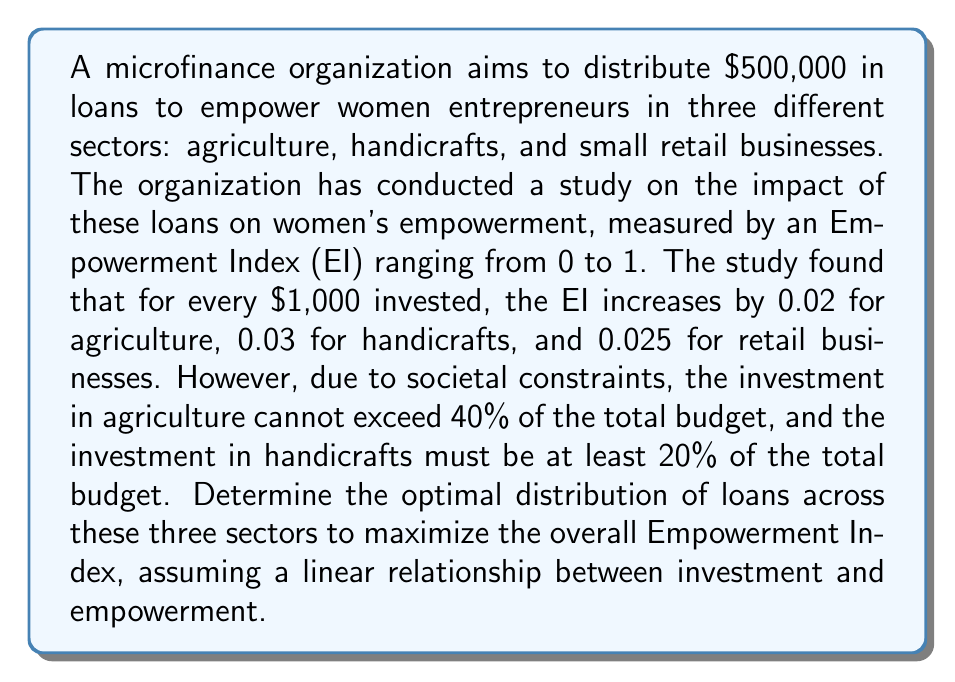Give your solution to this math problem. This problem can be solved using linear programming. Let's define our variables and constraints:

Variables:
$x_1$ = Amount invested in agriculture (in thousands of dollars)
$x_2$ = Amount invested in handicrafts (in thousands of dollars)
$x_3$ = Amount invested in retail businesses (in thousands of dollars)

Objective function:
Maximize $Z = 0.02x_1 + 0.03x_2 + 0.025x_3$

Constraints:
1. Total budget: $x_1 + x_2 + x_3 = 500$
2. Agriculture limit: $x_1 \leq 0.4 \times 500 = 200$
3. Handicrafts minimum: $x_2 \geq 0.2 \times 500 = 100$
4. Non-negativity: $x_1, x_2, x_3 \geq 0$

We can solve this using the simplex method or a linear programming solver. The optimal solution is:

$x_1 = 200$ (Agriculture)
$x_2 = 200$ (Handicrafts)
$x_3 = 100$ (Retail businesses)

To verify:
1. $200 + 200 + 100 = 500$ (Total budget constraint satisfied)
2. $200 \leq 200$ (Agriculture limit satisfied)
3. $200 \geq 100$ (Handicrafts minimum satisfied)
4. All values are non-negative

The maximum Empowerment Index achieved is:

$Z = 0.02(200) + 0.03(200) + 0.025(100) = 4 + 6 + 2.5 = 12.5$

This solution suggests that to maximize women's empowerment, the microfinance organization should invest:
- $200,000 in agriculture
- $200,000 in handicrafts
- $100,000 in retail businesses

This distribution takes into account the societal constraints while maximizing the overall impact on women's empowerment.
Answer: The optimal distribution of microfinance loans to maximize women's empowerment is:
Agriculture: $200,000
Handicrafts: $200,000
Retail businesses: $100,000
This distribution yields a maximum Empowerment Index of 12.5. 